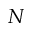<formula> <loc_0><loc_0><loc_500><loc_500>N</formula> 